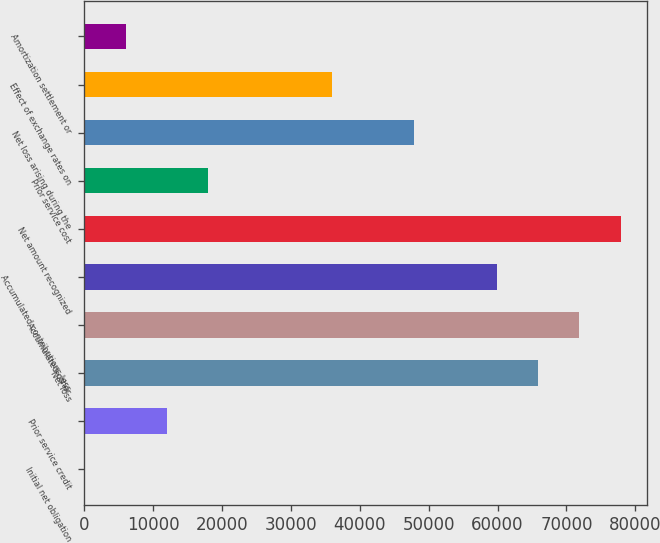Convert chart. <chart><loc_0><loc_0><loc_500><loc_500><bar_chart><fcel>Initial net obligation<fcel>Prior service credit<fcel>Net loss<fcel>Accumulated other<fcel>Accumulated contributions less<fcel>Net amount recognized<fcel>Prior service cost<fcel>Net loss arising during the<fcel>Effect of exchange rates on<fcel>Amortization settlement or<nl><fcel>10<fcel>11988<fcel>65889<fcel>71878<fcel>59900<fcel>77867<fcel>17977<fcel>47922<fcel>35944<fcel>5999<nl></chart> 